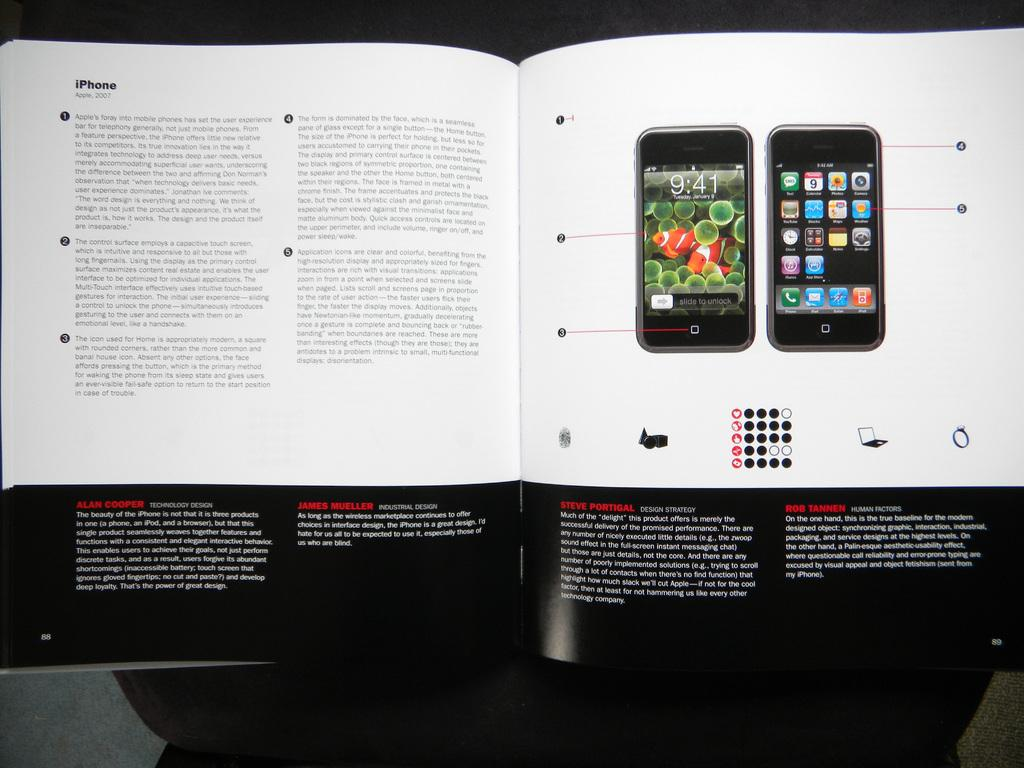<image>
Share a concise interpretation of the image provided. an open book opened up to a page titled iphone 